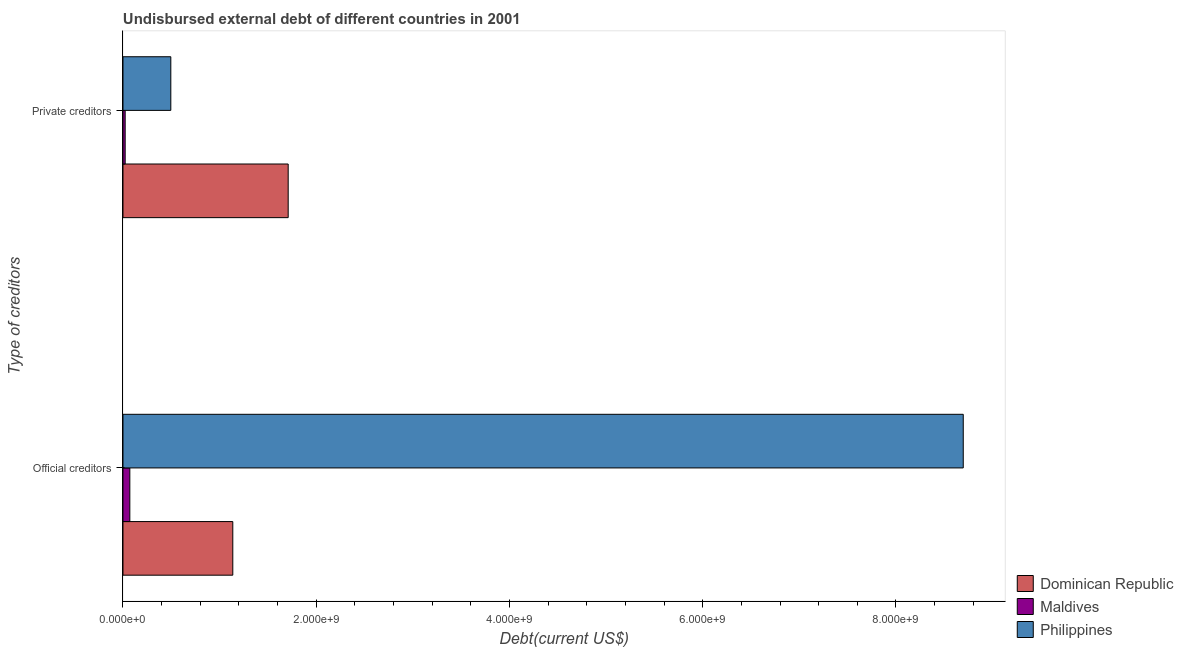How many different coloured bars are there?
Your answer should be very brief. 3. How many groups of bars are there?
Ensure brevity in your answer.  2. Are the number of bars per tick equal to the number of legend labels?
Your answer should be very brief. Yes. How many bars are there on the 2nd tick from the top?
Keep it short and to the point. 3. What is the label of the 1st group of bars from the top?
Your response must be concise. Private creditors. What is the undisbursed external debt of private creditors in Maldives?
Provide a succinct answer. 2.27e+07. Across all countries, what is the maximum undisbursed external debt of official creditors?
Ensure brevity in your answer.  8.70e+09. Across all countries, what is the minimum undisbursed external debt of official creditors?
Keep it short and to the point. 7.08e+07. In which country was the undisbursed external debt of private creditors maximum?
Ensure brevity in your answer.  Dominican Republic. In which country was the undisbursed external debt of private creditors minimum?
Your answer should be very brief. Maldives. What is the total undisbursed external debt of official creditors in the graph?
Offer a very short reply. 9.90e+09. What is the difference between the undisbursed external debt of private creditors in Dominican Republic and that in Maldives?
Provide a short and direct response. 1.69e+09. What is the difference between the undisbursed external debt of official creditors in Dominican Republic and the undisbursed external debt of private creditors in Philippines?
Your response must be concise. 6.42e+08. What is the average undisbursed external debt of private creditors per country?
Provide a short and direct response. 7.42e+08. What is the difference between the undisbursed external debt of official creditors and undisbursed external debt of private creditors in Maldives?
Provide a short and direct response. 4.81e+07. In how many countries, is the undisbursed external debt of official creditors greater than 2400000000 US$?
Provide a short and direct response. 1. What is the ratio of the undisbursed external debt of private creditors in Maldives to that in Philippines?
Your response must be concise. 0.05. Is the undisbursed external debt of private creditors in Philippines less than that in Dominican Republic?
Offer a terse response. Yes. What does the 3rd bar from the bottom in Private creditors represents?
Make the answer very short. Philippines. How many bars are there?
Keep it short and to the point. 6. How many countries are there in the graph?
Provide a succinct answer. 3. Are the values on the major ticks of X-axis written in scientific E-notation?
Your answer should be compact. Yes. Where does the legend appear in the graph?
Provide a short and direct response. Bottom right. How many legend labels are there?
Offer a very short reply. 3. How are the legend labels stacked?
Offer a terse response. Vertical. What is the title of the graph?
Your answer should be compact. Undisbursed external debt of different countries in 2001. Does "Fiji" appear as one of the legend labels in the graph?
Ensure brevity in your answer.  No. What is the label or title of the X-axis?
Your answer should be compact. Debt(current US$). What is the label or title of the Y-axis?
Make the answer very short. Type of creditors. What is the Debt(current US$) of Dominican Republic in Official creditors?
Your response must be concise. 1.14e+09. What is the Debt(current US$) in Maldives in Official creditors?
Provide a succinct answer. 7.08e+07. What is the Debt(current US$) in Philippines in Official creditors?
Give a very brief answer. 8.70e+09. What is the Debt(current US$) in Dominican Republic in Private creditors?
Ensure brevity in your answer.  1.71e+09. What is the Debt(current US$) in Maldives in Private creditors?
Provide a short and direct response. 2.27e+07. What is the Debt(current US$) of Philippines in Private creditors?
Your answer should be compact. 4.95e+08. Across all Type of creditors, what is the maximum Debt(current US$) of Dominican Republic?
Offer a terse response. 1.71e+09. Across all Type of creditors, what is the maximum Debt(current US$) in Maldives?
Your answer should be compact. 7.08e+07. Across all Type of creditors, what is the maximum Debt(current US$) of Philippines?
Make the answer very short. 8.70e+09. Across all Type of creditors, what is the minimum Debt(current US$) of Dominican Republic?
Provide a succinct answer. 1.14e+09. Across all Type of creditors, what is the minimum Debt(current US$) in Maldives?
Keep it short and to the point. 2.27e+07. Across all Type of creditors, what is the minimum Debt(current US$) in Philippines?
Ensure brevity in your answer.  4.95e+08. What is the total Debt(current US$) of Dominican Republic in the graph?
Provide a short and direct response. 2.85e+09. What is the total Debt(current US$) in Maldives in the graph?
Make the answer very short. 9.34e+07. What is the total Debt(current US$) in Philippines in the graph?
Offer a very short reply. 9.19e+09. What is the difference between the Debt(current US$) of Dominican Republic in Official creditors and that in Private creditors?
Provide a succinct answer. -5.73e+08. What is the difference between the Debt(current US$) in Maldives in Official creditors and that in Private creditors?
Your answer should be very brief. 4.81e+07. What is the difference between the Debt(current US$) in Philippines in Official creditors and that in Private creditors?
Provide a short and direct response. 8.20e+09. What is the difference between the Debt(current US$) in Dominican Republic in Official creditors and the Debt(current US$) in Maldives in Private creditors?
Make the answer very short. 1.11e+09. What is the difference between the Debt(current US$) in Dominican Republic in Official creditors and the Debt(current US$) in Philippines in Private creditors?
Provide a succinct answer. 6.42e+08. What is the difference between the Debt(current US$) of Maldives in Official creditors and the Debt(current US$) of Philippines in Private creditors?
Keep it short and to the point. -4.24e+08. What is the average Debt(current US$) in Dominican Republic per Type of creditors?
Your answer should be very brief. 1.42e+09. What is the average Debt(current US$) in Maldives per Type of creditors?
Ensure brevity in your answer.  4.67e+07. What is the average Debt(current US$) of Philippines per Type of creditors?
Provide a short and direct response. 4.60e+09. What is the difference between the Debt(current US$) of Dominican Republic and Debt(current US$) of Maldives in Official creditors?
Ensure brevity in your answer.  1.07e+09. What is the difference between the Debt(current US$) of Dominican Republic and Debt(current US$) of Philippines in Official creditors?
Give a very brief answer. -7.56e+09. What is the difference between the Debt(current US$) of Maldives and Debt(current US$) of Philippines in Official creditors?
Provide a short and direct response. -8.63e+09. What is the difference between the Debt(current US$) of Dominican Republic and Debt(current US$) of Maldives in Private creditors?
Offer a terse response. 1.69e+09. What is the difference between the Debt(current US$) in Dominican Republic and Debt(current US$) in Philippines in Private creditors?
Give a very brief answer. 1.21e+09. What is the difference between the Debt(current US$) in Maldives and Debt(current US$) in Philippines in Private creditors?
Make the answer very short. -4.72e+08. What is the ratio of the Debt(current US$) in Dominican Republic in Official creditors to that in Private creditors?
Your answer should be very brief. 0.66. What is the ratio of the Debt(current US$) of Maldives in Official creditors to that in Private creditors?
Provide a succinct answer. 3.13. What is the ratio of the Debt(current US$) of Philippines in Official creditors to that in Private creditors?
Keep it short and to the point. 17.57. What is the difference between the highest and the second highest Debt(current US$) in Dominican Republic?
Ensure brevity in your answer.  5.73e+08. What is the difference between the highest and the second highest Debt(current US$) in Maldives?
Ensure brevity in your answer.  4.81e+07. What is the difference between the highest and the second highest Debt(current US$) of Philippines?
Offer a terse response. 8.20e+09. What is the difference between the highest and the lowest Debt(current US$) in Dominican Republic?
Provide a succinct answer. 5.73e+08. What is the difference between the highest and the lowest Debt(current US$) in Maldives?
Offer a terse response. 4.81e+07. What is the difference between the highest and the lowest Debt(current US$) of Philippines?
Give a very brief answer. 8.20e+09. 